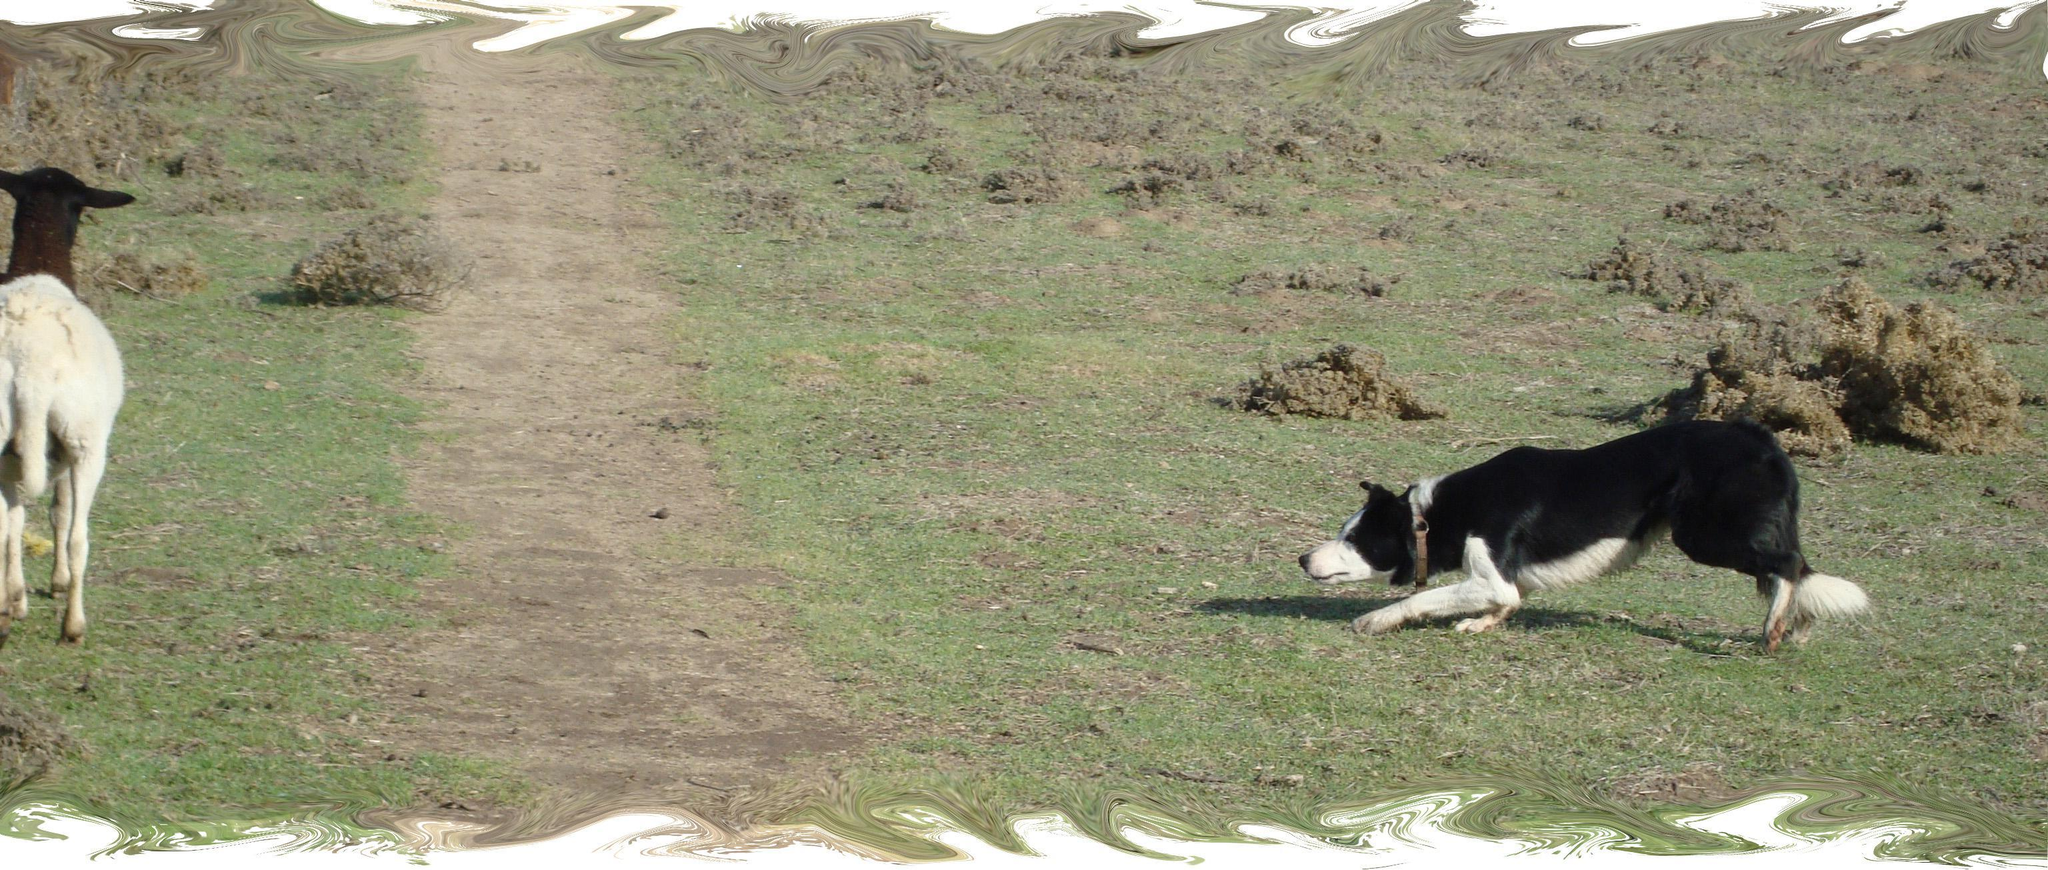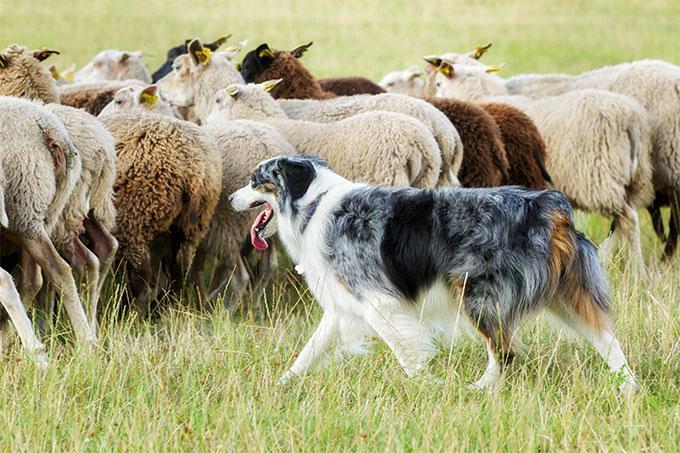The first image is the image on the left, the second image is the image on the right. Assess this claim about the two images: "One image has exactly three dogs.". Correct or not? Answer yes or no. No. 